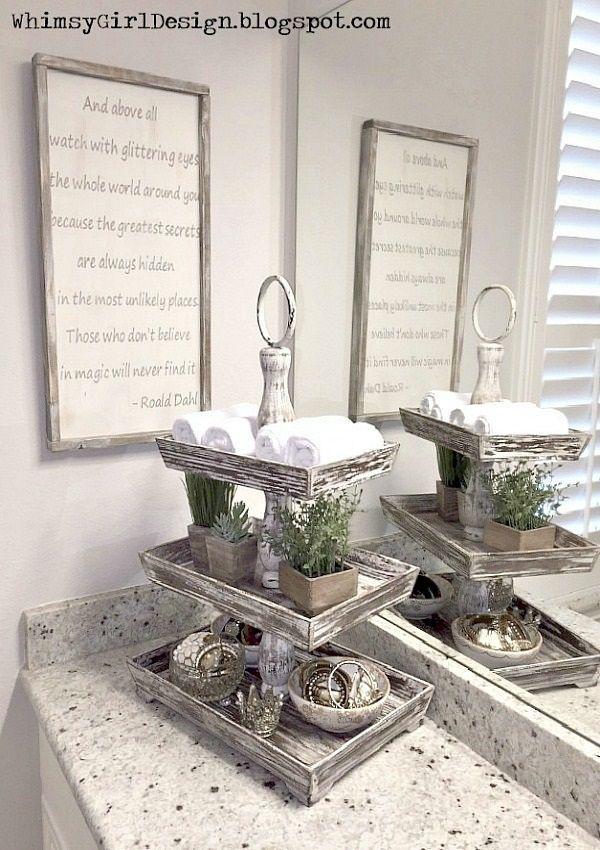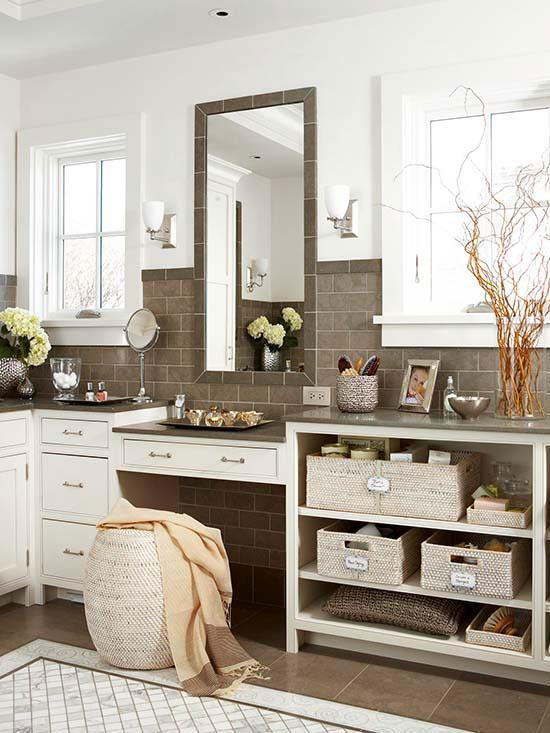The first image is the image on the left, the second image is the image on the right. Analyze the images presented: Is the assertion "There is a sink in one of the images." valid? Answer yes or no. No. 